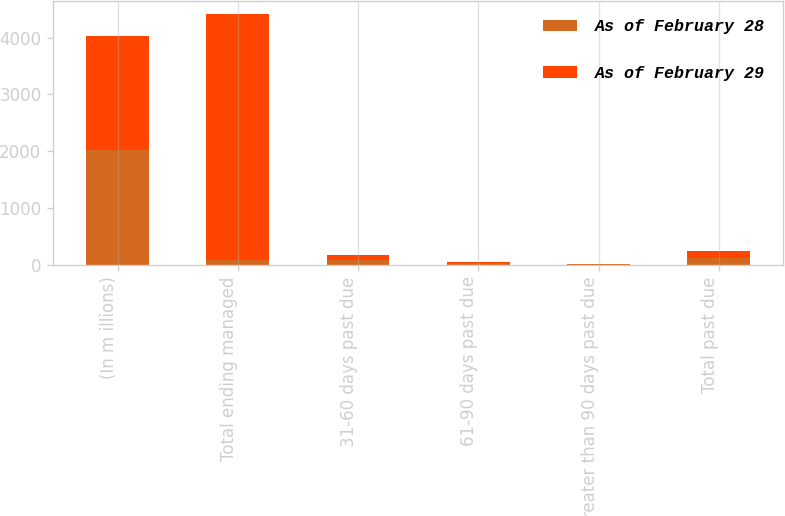Convert chart to OTSL. <chart><loc_0><loc_0><loc_500><loc_500><stacked_bar_chart><ecel><fcel>(In m illions)<fcel>Total ending managed<fcel>31-60 days past due<fcel>61-90 days past due<fcel>Greater than 90 days past due<fcel>Total past due<nl><fcel>As of February 28<fcel>2012<fcel>86.6<fcel>85.1<fcel>21.8<fcel>9.6<fcel>116.5<nl><fcel>As of February 29<fcel>2011<fcel>4334.6<fcel>86.6<fcel>24.2<fcel>10.5<fcel>121.3<nl></chart> 